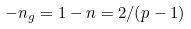<formula> <loc_0><loc_0><loc_500><loc_500>- n _ { g } = 1 - n = 2 / ( p - 1 )</formula> 